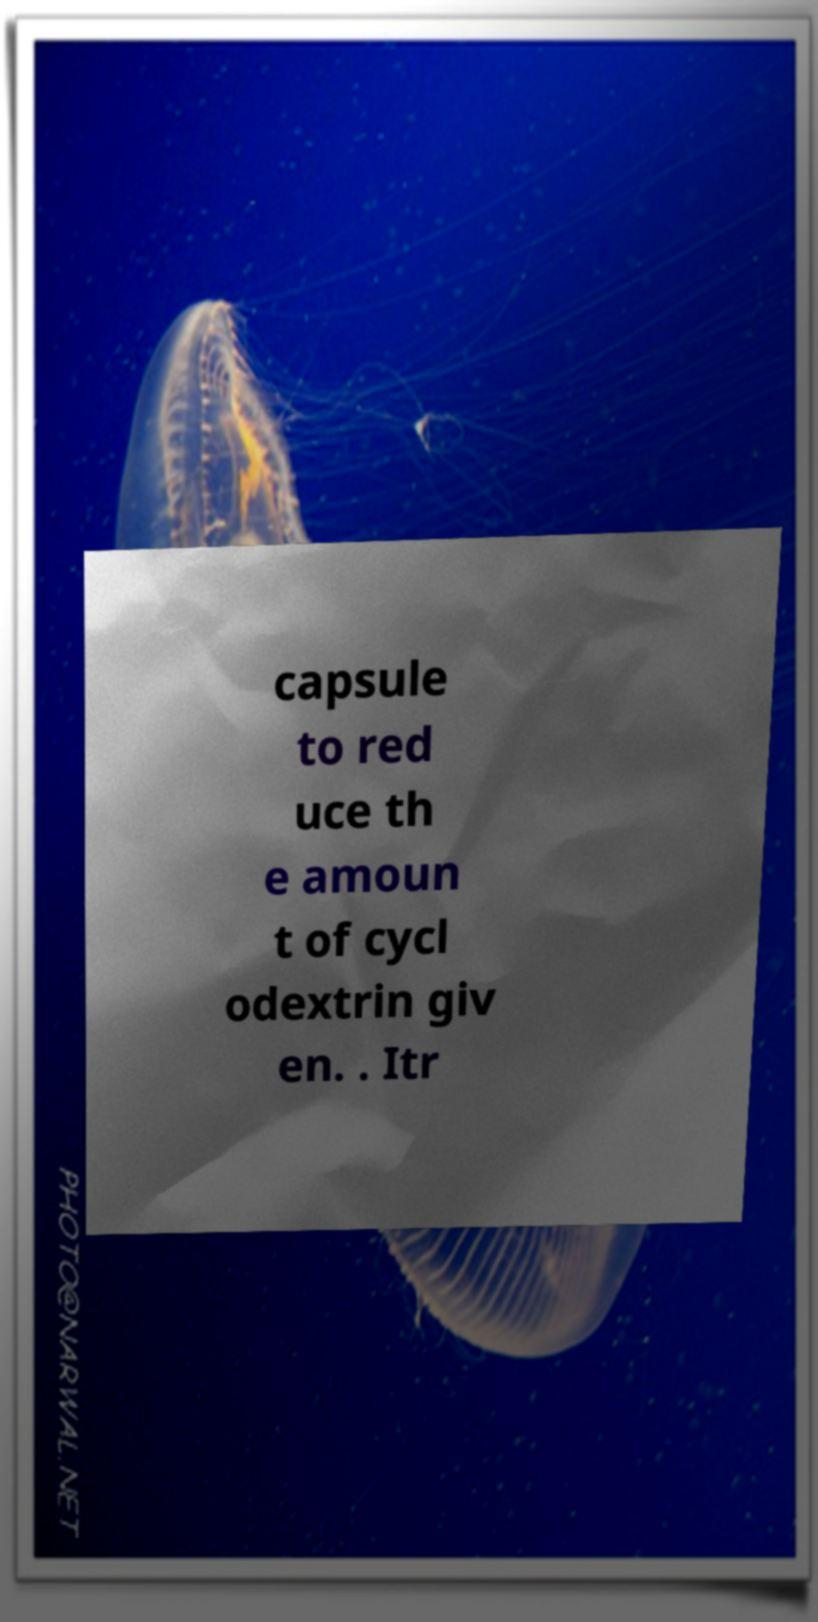Please read and relay the text visible in this image. What does it say? capsule to red uce th e amoun t of cycl odextrin giv en. . Itr 